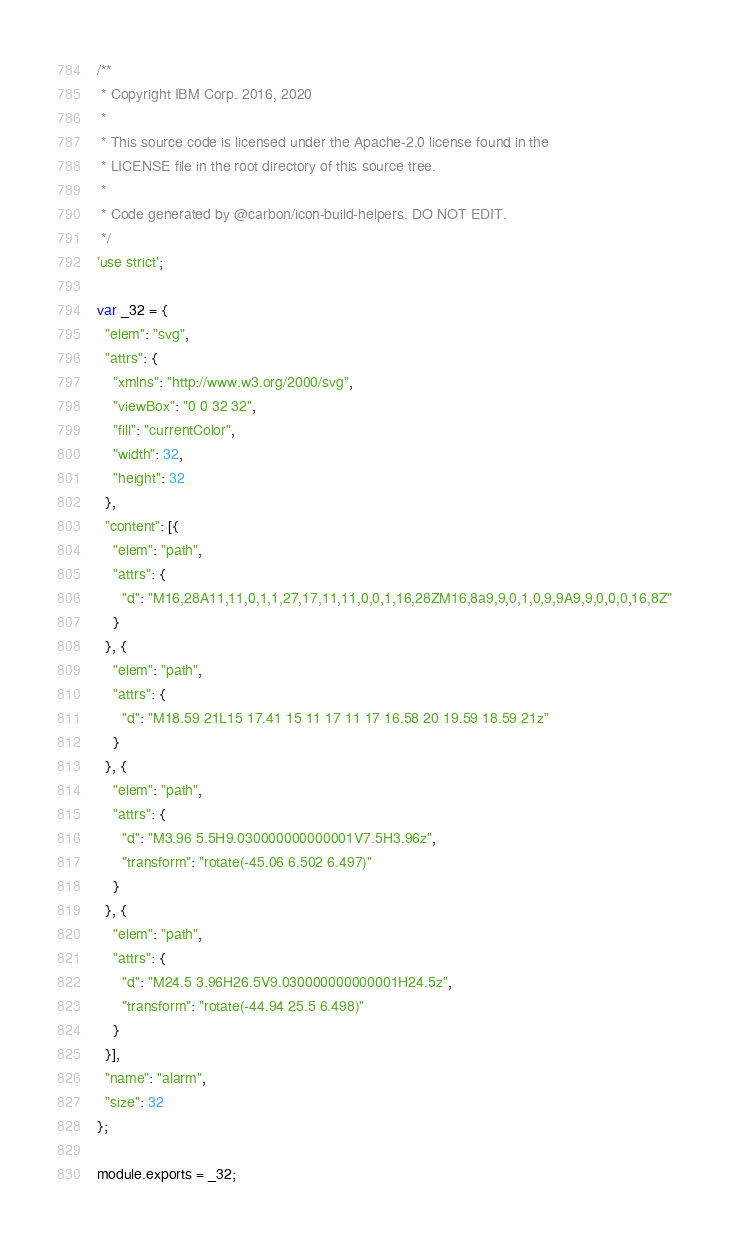<code> <loc_0><loc_0><loc_500><loc_500><_JavaScript_>/**
 * Copyright IBM Corp. 2016, 2020
 *
 * This source code is licensed under the Apache-2.0 license found in the
 * LICENSE file in the root directory of this source tree.
 *
 * Code generated by @carbon/icon-build-helpers. DO NOT EDIT.
 */
'use strict';

var _32 = {
  "elem": "svg",
  "attrs": {
    "xmlns": "http://www.w3.org/2000/svg",
    "viewBox": "0 0 32 32",
    "fill": "currentColor",
    "width": 32,
    "height": 32
  },
  "content": [{
    "elem": "path",
    "attrs": {
      "d": "M16,28A11,11,0,1,1,27,17,11,11,0,0,1,16,28ZM16,8a9,9,0,1,0,9,9A9,9,0,0,0,16,8Z"
    }
  }, {
    "elem": "path",
    "attrs": {
      "d": "M18.59 21L15 17.41 15 11 17 11 17 16.58 20 19.59 18.59 21z"
    }
  }, {
    "elem": "path",
    "attrs": {
      "d": "M3.96 5.5H9.030000000000001V7.5H3.96z",
      "transform": "rotate(-45.06 6.502 6.497)"
    }
  }, {
    "elem": "path",
    "attrs": {
      "d": "M24.5 3.96H26.5V9.030000000000001H24.5z",
      "transform": "rotate(-44.94 25.5 6.498)"
    }
  }],
  "name": "alarm",
  "size": 32
};

module.exports = _32;
</code> 